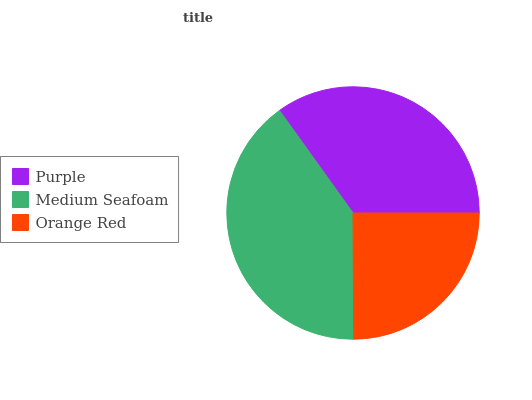Is Orange Red the minimum?
Answer yes or no. Yes. Is Medium Seafoam the maximum?
Answer yes or no. Yes. Is Medium Seafoam the minimum?
Answer yes or no. No. Is Orange Red the maximum?
Answer yes or no. No. Is Medium Seafoam greater than Orange Red?
Answer yes or no. Yes. Is Orange Red less than Medium Seafoam?
Answer yes or no. Yes. Is Orange Red greater than Medium Seafoam?
Answer yes or no. No. Is Medium Seafoam less than Orange Red?
Answer yes or no. No. Is Purple the high median?
Answer yes or no. Yes. Is Purple the low median?
Answer yes or no. Yes. Is Orange Red the high median?
Answer yes or no. No. Is Medium Seafoam the low median?
Answer yes or no. No. 